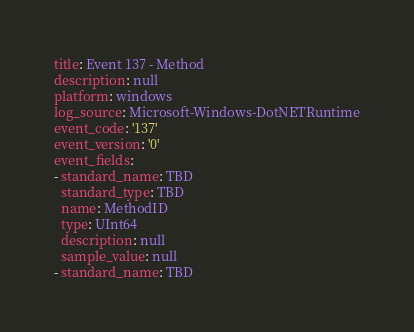<code> <loc_0><loc_0><loc_500><loc_500><_YAML_>title: Event 137 - Method
description: null
platform: windows
log_source: Microsoft-Windows-DotNETRuntime
event_code: '137'
event_version: '0'
event_fields:
- standard_name: TBD
  standard_type: TBD
  name: MethodID
  type: UInt64
  description: null
  sample_value: null
- standard_name: TBD</code> 